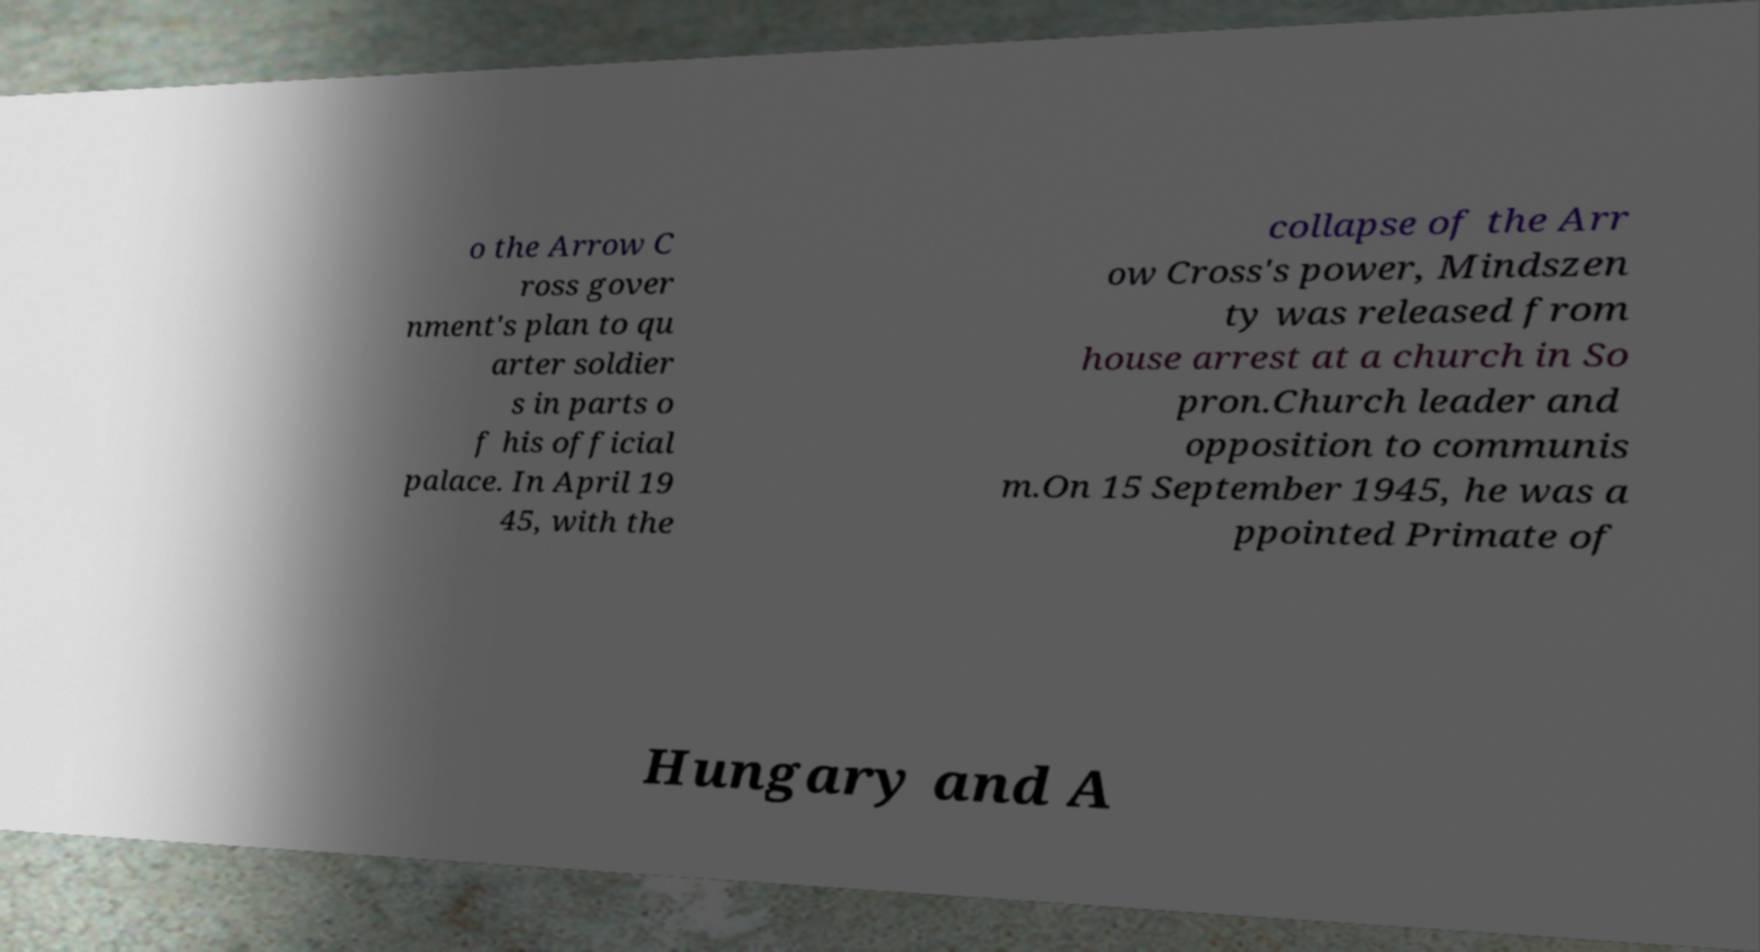I need the written content from this picture converted into text. Can you do that? o the Arrow C ross gover nment's plan to qu arter soldier s in parts o f his official palace. In April 19 45, with the collapse of the Arr ow Cross's power, Mindszen ty was released from house arrest at a church in So pron.Church leader and opposition to communis m.On 15 September 1945, he was a ppointed Primate of Hungary and A 